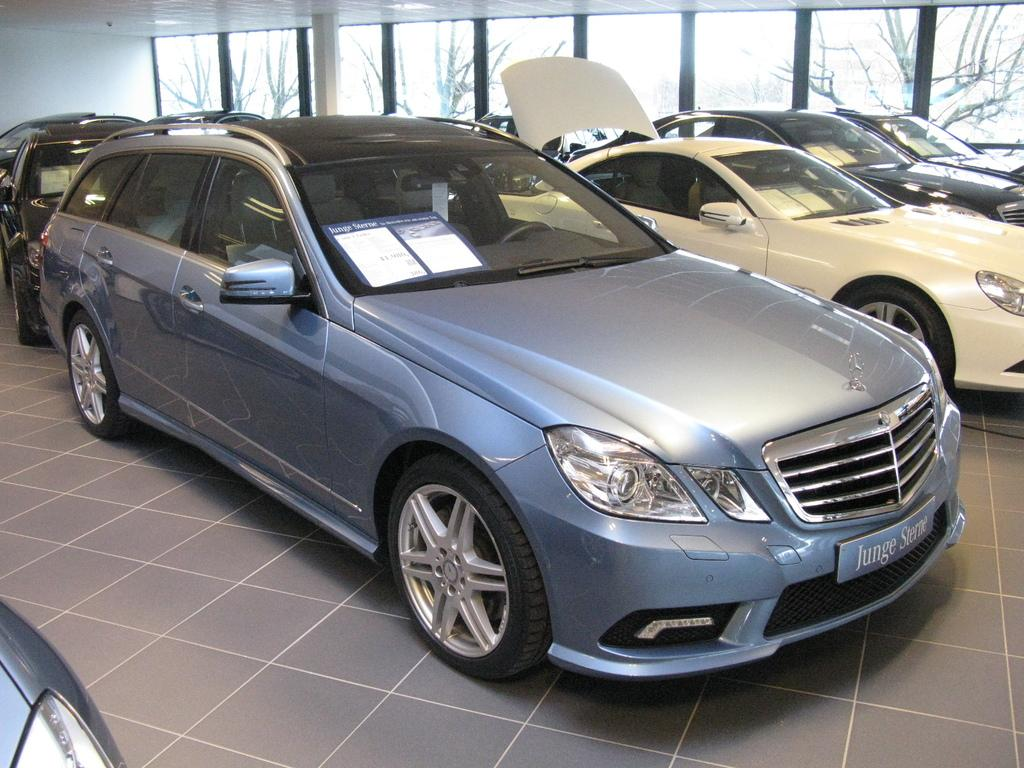What type of vehicles can be seen in the image? There are cars in the image. What is visible in the background of the image? There is a wall in the background of the image. What can be seen through the glass doors in the background of the image? Trees are visible through the glass doors in the background of the image. How many wishes are granted to the men in the image? There are no men present in the image, and therefore no wishes can be granted. What type of jar is visible in the image? There is no jar present in the image. 